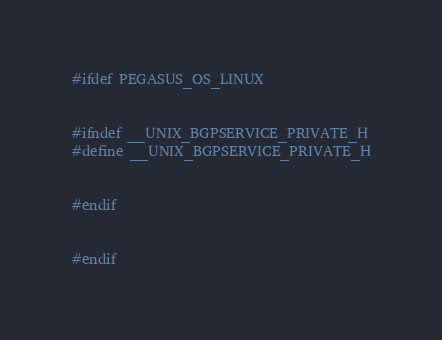<code> <loc_0><loc_0><loc_500><loc_500><_C++_>#ifdef PEGASUS_OS_LINUX


#ifndef __UNIX_BGPSERVICE_PRIVATE_H
#define __UNIX_BGPSERVICE_PRIVATE_H


#endif


#endif
</code> 